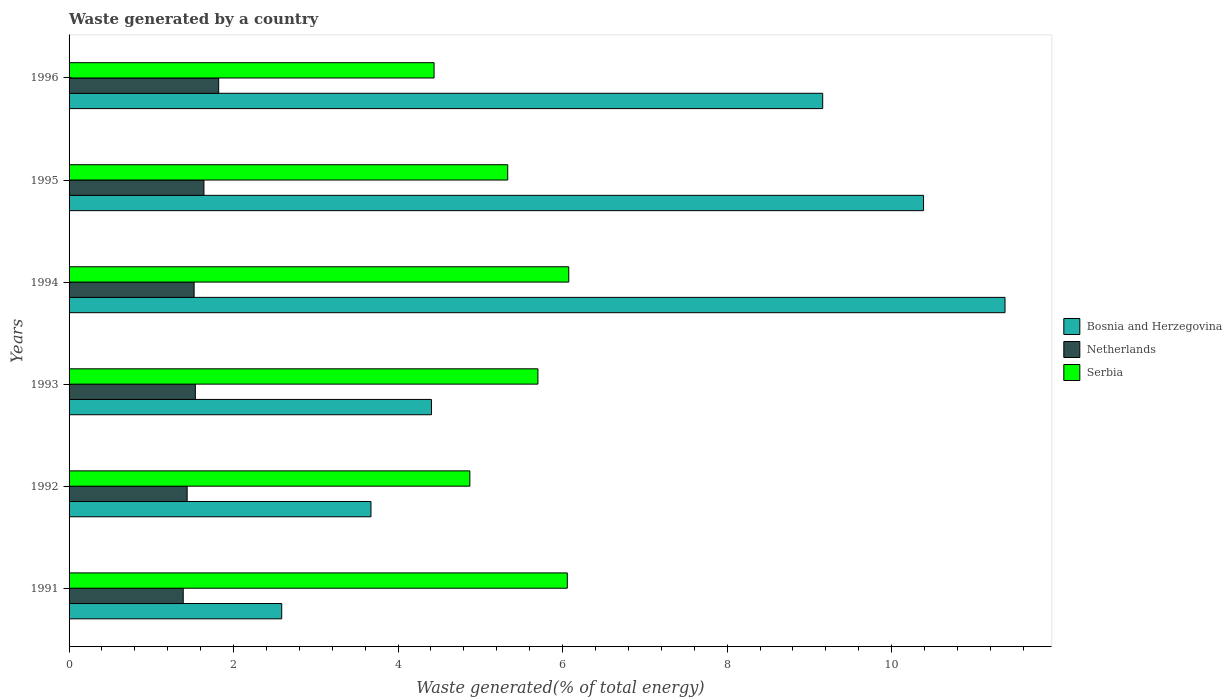Are the number of bars per tick equal to the number of legend labels?
Provide a short and direct response. Yes. How many bars are there on the 1st tick from the top?
Give a very brief answer. 3. How many bars are there on the 4th tick from the bottom?
Offer a very short reply. 3. In how many cases, is the number of bars for a given year not equal to the number of legend labels?
Provide a succinct answer. 0. What is the total waste generated in Serbia in 1993?
Your answer should be compact. 5.7. Across all years, what is the maximum total waste generated in Netherlands?
Make the answer very short. 1.82. Across all years, what is the minimum total waste generated in Serbia?
Your response must be concise. 4.44. In which year was the total waste generated in Netherlands maximum?
Make the answer very short. 1996. In which year was the total waste generated in Serbia minimum?
Offer a very short reply. 1996. What is the total total waste generated in Netherlands in the graph?
Keep it short and to the point. 9.34. What is the difference between the total waste generated in Serbia in 1991 and that in 1996?
Keep it short and to the point. 1.62. What is the difference between the total waste generated in Bosnia and Herzegovina in 1996 and the total waste generated in Serbia in 1991?
Offer a terse response. 3.1. What is the average total waste generated in Serbia per year?
Offer a terse response. 5.41. In the year 1993, what is the difference between the total waste generated in Bosnia and Herzegovina and total waste generated in Netherlands?
Your answer should be compact. 2.87. What is the ratio of the total waste generated in Serbia in 1991 to that in 1995?
Provide a short and direct response. 1.14. What is the difference between the highest and the second highest total waste generated in Bosnia and Herzegovina?
Your answer should be very brief. 0.99. What is the difference between the highest and the lowest total waste generated in Serbia?
Your response must be concise. 1.64. What does the 1st bar from the top in 1991 represents?
Provide a short and direct response. Serbia. What does the 2nd bar from the bottom in 1995 represents?
Ensure brevity in your answer.  Netherlands. Is it the case that in every year, the sum of the total waste generated in Netherlands and total waste generated in Serbia is greater than the total waste generated in Bosnia and Herzegovina?
Your answer should be compact. No. How many bars are there?
Provide a short and direct response. 18. Does the graph contain any zero values?
Your response must be concise. No. How many legend labels are there?
Offer a very short reply. 3. What is the title of the graph?
Give a very brief answer. Waste generated by a country. What is the label or title of the X-axis?
Your response must be concise. Waste generated(% of total energy). What is the label or title of the Y-axis?
Offer a very short reply. Years. What is the Waste generated(% of total energy) in Bosnia and Herzegovina in 1991?
Your answer should be very brief. 2.59. What is the Waste generated(% of total energy) of Netherlands in 1991?
Offer a very short reply. 1.39. What is the Waste generated(% of total energy) of Serbia in 1991?
Ensure brevity in your answer.  6.06. What is the Waste generated(% of total energy) of Bosnia and Herzegovina in 1992?
Your answer should be very brief. 3.67. What is the Waste generated(% of total energy) in Netherlands in 1992?
Ensure brevity in your answer.  1.44. What is the Waste generated(% of total energy) in Serbia in 1992?
Provide a short and direct response. 4.87. What is the Waste generated(% of total energy) in Bosnia and Herzegovina in 1993?
Give a very brief answer. 4.41. What is the Waste generated(% of total energy) in Netherlands in 1993?
Make the answer very short. 1.54. What is the Waste generated(% of total energy) in Serbia in 1993?
Your response must be concise. 5.7. What is the Waste generated(% of total energy) of Bosnia and Herzegovina in 1994?
Give a very brief answer. 11.38. What is the Waste generated(% of total energy) in Netherlands in 1994?
Your answer should be very brief. 1.52. What is the Waste generated(% of total energy) of Serbia in 1994?
Make the answer very short. 6.08. What is the Waste generated(% of total energy) in Bosnia and Herzegovina in 1995?
Make the answer very short. 10.39. What is the Waste generated(% of total energy) of Netherlands in 1995?
Offer a very short reply. 1.64. What is the Waste generated(% of total energy) in Serbia in 1995?
Keep it short and to the point. 5.33. What is the Waste generated(% of total energy) of Bosnia and Herzegovina in 1996?
Your response must be concise. 9.16. What is the Waste generated(% of total energy) of Netherlands in 1996?
Make the answer very short. 1.82. What is the Waste generated(% of total energy) of Serbia in 1996?
Keep it short and to the point. 4.44. Across all years, what is the maximum Waste generated(% of total energy) of Bosnia and Herzegovina?
Ensure brevity in your answer.  11.38. Across all years, what is the maximum Waste generated(% of total energy) of Netherlands?
Offer a terse response. 1.82. Across all years, what is the maximum Waste generated(% of total energy) in Serbia?
Give a very brief answer. 6.08. Across all years, what is the minimum Waste generated(% of total energy) of Bosnia and Herzegovina?
Make the answer very short. 2.59. Across all years, what is the minimum Waste generated(% of total energy) of Netherlands?
Provide a short and direct response. 1.39. Across all years, what is the minimum Waste generated(% of total energy) of Serbia?
Your answer should be very brief. 4.44. What is the total Waste generated(% of total energy) in Bosnia and Herzegovina in the graph?
Keep it short and to the point. 41.59. What is the total Waste generated(% of total energy) in Netherlands in the graph?
Offer a very short reply. 9.34. What is the total Waste generated(% of total energy) of Serbia in the graph?
Offer a very short reply. 32.48. What is the difference between the Waste generated(% of total energy) of Bosnia and Herzegovina in 1991 and that in 1992?
Your response must be concise. -1.09. What is the difference between the Waste generated(% of total energy) in Netherlands in 1991 and that in 1992?
Give a very brief answer. -0.05. What is the difference between the Waste generated(% of total energy) of Serbia in 1991 and that in 1992?
Your answer should be compact. 1.18. What is the difference between the Waste generated(% of total energy) of Bosnia and Herzegovina in 1991 and that in 1993?
Your answer should be very brief. -1.82. What is the difference between the Waste generated(% of total energy) in Netherlands in 1991 and that in 1993?
Provide a short and direct response. -0.15. What is the difference between the Waste generated(% of total energy) in Serbia in 1991 and that in 1993?
Give a very brief answer. 0.36. What is the difference between the Waste generated(% of total energy) of Bosnia and Herzegovina in 1991 and that in 1994?
Your answer should be very brief. -8.79. What is the difference between the Waste generated(% of total energy) in Netherlands in 1991 and that in 1994?
Your answer should be very brief. -0.13. What is the difference between the Waste generated(% of total energy) in Serbia in 1991 and that in 1994?
Provide a short and direct response. -0.02. What is the difference between the Waste generated(% of total energy) of Bosnia and Herzegovina in 1991 and that in 1995?
Your response must be concise. -7.8. What is the difference between the Waste generated(% of total energy) in Netherlands in 1991 and that in 1995?
Give a very brief answer. -0.25. What is the difference between the Waste generated(% of total energy) of Serbia in 1991 and that in 1995?
Keep it short and to the point. 0.72. What is the difference between the Waste generated(% of total energy) of Bosnia and Herzegovina in 1991 and that in 1996?
Provide a succinct answer. -6.58. What is the difference between the Waste generated(% of total energy) of Netherlands in 1991 and that in 1996?
Offer a very short reply. -0.43. What is the difference between the Waste generated(% of total energy) in Serbia in 1991 and that in 1996?
Provide a succinct answer. 1.62. What is the difference between the Waste generated(% of total energy) in Bosnia and Herzegovina in 1992 and that in 1993?
Your answer should be compact. -0.74. What is the difference between the Waste generated(% of total energy) of Netherlands in 1992 and that in 1993?
Your response must be concise. -0.1. What is the difference between the Waste generated(% of total energy) in Serbia in 1992 and that in 1993?
Your answer should be compact. -0.83. What is the difference between the Waste generated(% of total energy) of Bosnia and Herzegovina in 1992 and that in 1994?
Give a very brief answer. -7.71. What is the difference between the Waste generated(% of total energy) in Netherlands in 1992 and that in 1994?
Provide a succinct answer. -0.08. What is the difference between the Waste generated(% of total energy) in Serbia in 1992 and that in 1994?
Make the answer very short. -1.2. What is the difference between the Waste generated(% of total energy) of Bosnia and Herzegovina in 1992 and that in 1995?
Offer a very short reply. -6.72. What is the difference between the Waste generated(% of total energy) of Netherlands in 1992 and that in 1995?
Ensure brevity in your answer.  -0.2. What is the difference between the Waste generated(% of total energy) of Serbia in 1992 and that in 1995?
Your response must be concise. -0.46. What is the difference between the Waste generated(% of total energy) in Bosnia and Herzegovina in 1992 and that in 1996?
Make the answer very short. -5.49. What is the difference between the Waste generated(% of total energy) of Netherlands in 1992 and that in 1996?
Ensure brevity in your answer.  -0.38. What is the difference between the Waste generated(% of total energy) in Serbia in 1992 and that in 1996?
Keep it short and to the point. 0.43. What is the difference between the Waste generated(% of total energy) of Bosnia and Herzegovina in 1993 and that in 1994?
Provide a succinct answer. -6.97. What is the difference between the Waste generated(% of total energy) in Netherlands in 1993 and that in 1994?
Your answer should be compact. 0.01. What is the difference between the Waste generated(% of total energy) of Serbia in 1993 and that in 1994?
Offer a very short reply. -0.38. What is the difference between the Waste generated(% of total energy) in Bosnia and Herzegovina in 1993 and that in 1995?
Provide a succinct answer. -5.98. What is the difference between the Waste generated(% of total energy) in Netherlands in 1993 and that in 1995?
Your answer should be compact. -0.1. What is the difference between the Waste generated(% of total energy) in Serbia in 1993 and that in 1995?
Provide a succinct answer. 0.37. What is the difference between the Waste generated(% of total energy) in Bosnia and Herzegovina in 1993 and that in 1996?
Make the answer very short. -4.76. What is the difference between the Waste generated(% of total energy) of Netherlands in 1993 and that in 1996?
Your answer should be compact. -0.28. What is the difference between the Waste generated(% of total energy) of Serbia in 1993 and that in 1996?
Provide a succinct answer. 1.26. What is the difference between the Waste generated(% of total energy) in Bosnia and Herzegovina in 1994 and that in 1995?
Your answer should be very brief. 0.99. What is the difference between the Waste generated(% of total energy) of Netherlands in 1994 and that in 1995?
Your answer should be compact. -0.12. What is the difference between the Waste generated(% of total energy) in Serbia in 1994 and that in 1995?
Keep it short and to the point. 0.74. What is the difference between the Waste generated(% of total energy) in Bosnia and Herzegovina in 1994 and that in 1996?
Ensure brevity in your answer.  2.22. What is the difference between the Waste generated(% of total energy) of Netherlands in 1994 and that in 1996?
Your answer should be very brief. -0.3. What is the difference between the Waste generated(% of total energy) in Serbia in 1994 and that in 1996?
Your answer should be compact. 1.64. What is the difference between the Waste generated(% of total energy) of Bosnia and Herzegovina in 1995 and that in 1996?
Your answer should be compact. 1.23. What is the difference between the Waste generated(% of total energy) in Netherlands in 1995 and that in 1996?
Your answer should be compact. -0.18. What is the difference between the Waste generated(% of total energy) in Serbia in 1995 and that in 1996?
Your answer should be compact. 0.9. What is the difference between the Waste generated(% of total energy) in Bosnia and Herzegovina in 1991 and the Waste generated(% of total energy) in Netherlands in 1992?
Offer a terse response. 1.15. What is the difference between the Waste generated(% of total energy) of Bosnia and Herzegovina in 1991 and the Waste generated(% of total energy) of Serbia in 1992?
Offer a terse response. -2.29. What is the difference between the Waste generated(% of total energy) in Netherlands in 1991 and the Waste generated(% of total energy) in Serbia in 1992?
Ensure brevity in your answer.  -3.48. What is the difference between the Waste generated(% of total energy) in Bosnia and Herzegovina in 1991 and the Waste generated(% of total energy) in Netherlands in 1993?
Offer a very short reply. 1.05. What is the difference between the Waste generated(% of total energy) of Bosnia and Herzegovina in 1991 and the Waste generated(% of total energy) of Serbia in 1993?
Give a very brief answer. -3.12. What is the difference between the Waste generated(% of total energy) in Netherlands in 1991 and the Waste generated(% of total energy) in Serbia in 1993?
Ensure brevity in your answer.  -4.31. What is the difference between the Waste generated(% of total energy) in Bosnia and Herzegovina in 1991 and the Waste generated(% of total energy) in Netherlands in 1994?
Provide a succinct answer. 1.06. What is the difference between the Waste generated(% of total energy) in Bosnia and Herzegovina in 1991 and the Waste generated(% of total energy) in Serbia in 1994?
Ensure brevity in your answer.  -3.49. What is the difference between the Waste generated(% of total energy) of Netherlands in 1991 and the Waste generated(% of total energy) of Serbia in 1994?
Offer a very short reply. -4.69. What is the difference between the Waste generated(% of total energy) of Bosnia and Herzegovina in 1991 and the Waste generated(% of total energy) of Netherlands in 1995?
Ensure brevity in your answer.  0.95. What is the difference between the Waste generated(% of total energy) in Bosnia and Herzegovina in 1991 and the Waste generated(% of total energy) in Serbia in 1995?
Make the answer very short. -2.75. What is the difference between the Waste generated(% of total energy) of Netherlands in 1991 and the Waste generated(% of total energy) of Serbia in 1995?
Your response must be concise. -3.95. What is the difference between the Waste generated(% of total energy) in Bosnia and Herzegovina in 1991 and the Waste generated(% of total energy) in Netherlands in 1996?
Offer a very short reply. 0.77. What is the difference between the Waste generated(% of total energy) in Bosnia and Herzegovina in 1991 and the Waste generated(% of total energy) in Serbia in 1996?
Offer a very short reply. -1.85. What is the difference between the Waste generated(% of total energy) of Netherlands in 1991 and the Waste generated(% of total energy) of Serbia in 1996?
Keep it short and to the point. -3.05. What is the difference between the Waste generated(% of total energy) of Bosnia and Herzegovina in 1992 and the Waste generated(% of total energy) of Netherlands in 1993?
Your answer should be very brief. 2.14. What is the difference between the Waste generated(% of total energy) of Bosnia and Herzegovina in 1992 and the Waste generated(% of total energy) of Serbia in 1993?
Offer a very short reply. -2.03. What is the difference between the Waste generated(% of total energy) of Netherlands in 1992 and the Waste generated(% of total energy) of Serbia in 1993?
Offer a very short reply. -4.26. What is the difference between the Waste generated(% of total energy) in Bosnia and Herzegovina in 1992 and the Waste generated(% of total energy) in Netherlands in 1994?
Your answer should be compact. 2.15. What is the difference between the Waste generated(% of total energy) of Bosnia and Herzegovina in 1992 and the Waste generated(% of total energy) of Serbia in 1994?
Keep it short and to the point. -2.4. What is the difference between the Waste generated(% of total energy) of Netherlands in 1992 and the Waste generated(% of total energy) of Serbia in 1994?
Your response must be concise. -4.64. What is the difference between the Waste generated(% of total energy) of Bosnia and Herzegovina in 1992 and the Waste generated(% of total energy) of Netherlands in 1995?
Provide a succinct answer. 2.03. What is the difference between the Waste generated(% of total energy) of Bosnia and Herzegovina in 1992 and the Waste generated(% of total energy) of Serbia in 1995?
Your answer should be compact. -1.66. What is the difference between the Waste generated(% of total energy) of Netherlands in 1992 and the Waste generated(% of total energy) of Serbia in 1995?
Your response must be concise. -3.9. What is the difference between the Waste generated(% of total energy) in Bosnia and Herzegovina in 1992 and the Waste generated(% of total energy) in Netherlands in 1996?
Give a very brief answer. 1.85. What is the difference between the Waste generated(% of total energy) in Bosnia and Herzegovina in 1992 and the Waste generated(% of total energy) in Serbia in 1996?
Offer a terse response. -0.77. What is the difference between the Waste generated(% of total energy) in Netherlands in 1992 and the Waste generated(% of total energy) in Serbia in 1996?
Your answer should be very brief. -3. What is the difference between the Waste generated(% of total energy) in Bosnia and Herzegovina in 1993 and the Waste generated(% of total energy) in Netherlands in 1994?
Your answer should be compact. 2.89. What is the difference between the Waste generated(% of total energy) in Bosnia and Herzegovina in 1993 and the Waste generated(% of total energy) in Serbia in 1994?
Provide a short and direct response. -1.67. What is the difference between the Waste generated(% of total energy) in Netherlands in 1993 and the Waste generated(% of total energy) in Serbia in 1994?
Make the answer very short. -4.54. What is the difference between the Waste generated(% of total energy) of Bosnia and Herzegovina in 1993 and the Waste generated(% of total energy) of Netherlands in 1995?
Keep it short and to the point. 2.77. What is the difference between the Waste generated(% of total energy) in Bosnia and Herzegovina in 1993 and the Waste generated(% of total energy) in Serbia in 1995?
Offer a terse response. -0.93. What is the difference between the Waste generated(% of total energy) in Netherlands in 1993 and the Waste generated(% of total energy) in Serbia in 1995?
Offer a very short reply. -3.8. What is the difference between the Waste generated(% of total energy) of Bosnia and Herzegovina in 1993 and the Waste generated(% of total energy) of Netherlands in 1996?
Offer a terse response. 2.59. What is the difference between the Waste generated(% of total energy) of Bosnia and Herzegovina in 1993 and the Waste generated(% of total energy) of Serbia in 1996?
Provide a short and direct response. -0.03. What is the difference between the Waste generated(% of total energy) in Netherlands in 1993 and the Waste generated(% of total energy) in Serbia in 1996?
Your answer should be compact. -2.9. What is the difference between the Waste generated(% of total energy) in Bosnia and Herzegovina in 1994 and the Waste generated(% of total energy) in Netherlands in 1995?
Make the answer very short. 9.74. What is the difference between the Waste generated(% of total energy) of Bosnia and Herzegovina in 1994 and the Waste generated(% of total energy) of Serbia in 1995?
Your answer should be very brief. 6.05. What is the difference between the Waste generated(% of total energy) of Netherlands in 1994 and the Waste generated(% of total energy) of Serbia in 1995?
Your answer should be very brief. -3.81. What is the difference between the Waste generated(% of total energy) of Bosnia and Herzegovina in 1994 and the Waste generated(% of total energy) of Netherlands in 1996?
Offer a very short reply. 9.56. What is the difference between the Waste generated(% of total energy) in Bosnia and Herzegovina in 1994 and the Waste generated(% of total energy) in Serbia in 1996?
Offer a terse response. 6.94. What is the difference between the Waste generated(% of total energy) in Netherlands in 1994 and the Waste generated(% of total energy) in Serbia in 1996?
Give a very brief answer. -2.92. What is the difference between the Waste generated(% of total energy) of Bosnia and Herzegovina in 1995 and the Waste generated(% of total energy) of Netherlands in 1996?
Your response must be concise. 8.57. What is the difference between the Waste generated(% of total energy) of Bosnia and Herzegovina in 1995 and the Waste generated(% of total energy) of Serbia in 1996?
Offer a terse response. 5.95. What is the difference between the Waste generated(% of total energy) in Netherlands in 1995 and the Waste generated(% of total energy) in Serbia in 1996?
Provide a short and direct response. -2.8. What is the average Waste generated(% of total energy) of Bosnia and Herzegovina per year?
Offer a very short reply. 6.93. What is the average Waste generated(% of total energy) of Netherlands per year?
Your answer should be compact. 1.56. What is the average Waste generated(% of total energy) in Serbia per year?
Your answer should be compact. 5.41. In the year 1991, what is the difference between the Waste generated(% of total energy) in Bosnia and Herzegovina and Waste generated(% of total energy) in Netherlands?
Ensure brevity in your answer.  1.2. In the year 1991, what is the difference between the Waste generated(% of total energy) of Bosnia and Herzegovina and Waste generated(% of total energy) of Serbia?
Your answer should be compact. -3.47. In the year 1991, what is the difference between the Waste generated(% of total energy) of Netherlands and Waste generated(% of total energy) of Serbia?
Provide a short and direct response. -4.67. In the year 1992, what is the difference between the Waste generated(% of total energy) in Bosnia and Herzegovina and Waste generated(% of total energy) in Netherlands?
Offer a terse response. 2.23. In the year 1992, what is the difference between the Waste generated(% of total energy) of Bosnia and Herzegovina and Waste generated(% of total energy) of Serbia?
Offer a terse response. -1.2. In the year 1992, what is the difference between the Waste generated(% of total energy) of Netherlands and Waste generated(% of total energy) of Serbia?
Your answer should be compact. -3.44. In the year 1993, what is the difference between the Waste generated(% of total energy) of Bosnia and Herzegovina and Waste generated(% of total energy) of Netherlands?
Offer a very short reply. 2.87. In the year 1993, what is the difference between the Waste generated(% of total energy) in Bosnia and Herzegovina and Waste generated(% of total energy) in Serbia?
Your response must be concise. -1.29. In the year 1993, what is the difference between the Waste generated(% of total energy) of Netherlands and Waste generated(% of total energy) of Serbia?
Your answer should be very brief. -4.16. In the year 1994, what is the difference between the Waste generated(% of total energy) in Bosnia and Herzegovina and Waste generated(% of total energy) in Netherlands?
Keep it short and to the point. 9.86. In the year 1994, what is the difference between the Waste generated(% of total energy) in Bosnia and Herzegovina and Waste generated(% of total energy) in Serbia?
Make the answer very short. 5.3. In the year 1994, what is the difference between the Waste generated(% of total energy) of Netherlands and Waste generated(% of total energy) of Serbia?
Keep it short and to the point. -4.55. In the year 1995, what is the difference between the Waste generated(% of total energy) in Bosnia and Herzegovina and Waste generated(% of total energy) in Netherlands?
Your answer should be very brief. 8.75. In the year 1995, what is the difference between the Waste generated(% of total energy) of Bosnia and Herzegovina and Waste generated(% of total energy) of Serbia?
Make the answer very short. 5.06. In the year 1995, what is the difference between the Waste generated(% of total energy) in Netherlands and Waste generated(% of total energy) in Serbia?
Give a very brief answer. -3.69. In the year 1996, what is the difference between the Waste generated(% of total energy) of Bosnia and Herzegovina and Waste generated(% of total energy) of Netherlands?
Ensure brevity in your answer.  7.34. In the year 1996, what is the difference between the Waste generated(% of total energy) in Bosnia and Herzegovina and Waste generated(% of total energy) in Serbia?
Your answer should be very brief. 4.72. In the year 1996, what is the difference between the Waste generated(% of total energy) in Netherlands and Waste generated(% of total energy) in Serbia?
Offer a terse response. -2.62. What is the ratio of the Waste generated(% of total energy) of Bosnia and Herzegovina in 1991 to that in 1992?
Your answer should be compact. 0.7. What is the ratio of the Waste generated(% of total energy) of Netherlands in 1991 to that in 1992?
Provide a short and direct response. 0.97. What is the ratio of the Waste generated(% of total energy) in Serbia in 1991 to that in 1992?
Make the answer very short. 1.24. What is the ratio of the Waste generated(% of total energy) of Bosnia and Herzegovina in 1991 to that in 1993?
Give a very brief answer. 0.59. What is the ratio of the Waste generated(% of total energy) in Netherlands in 1991 to that in 1993?
Your response must be concise. 0.9. What is the ratio of the Waste generated(% of total energy) of Serbia in 1991 to that in 1993?
Your answer should be compact. 1.06. What is the ratio of the Waste generated(% of total energy) in Bosnia and Herzegovina in 1991 to that in 1994?
Offer a very short reply. 0.23. What is the ratio of the Waste generated(% of total energy) of Netherlands in 1991 to that in 1994?
Make the answer very short. 0.91. What is the ratio of the Waste generated(% of total energy) of Bosnia and Herzegovina in 1991 to that in 1995?
Provide a short and direct response. 0.25. What is the ratio of the Waste generated(% of total energy) in Netherlands in 1991 to that in 1995?
Keep it short and to the point. 0.85. What is the ratio of the Waste generated(% of total energy) of Serbia in 1991 to that in 1995?
Offer a very short reply. 1.14. What is the ratio of the Waste generated(% of total energy) of Bosnia and Herzegovina in 1991 to that in 1996?
Offer a terse response. 0.28. What is the ratio of the Waste generated(% of total energy) of Netherlands in 1991 to that in 1996?
Provide a short and direct response. 0.76. What is the ratio of the Waste generated(% of total energy) of Serbia in 1991 to that in 1996?
Ensure brevity in your answer.  1.36. What is the ratio of the Waste generated(% of total energy) in Bosnia and Herzegovina in 1992 to that in 1993?
Ensure brevity in your answer.  0.83. What is the ratio of the Waste generated(% of total energy) in Netherlands in 1992 to that in 1993?
Provide a short and direct response. 0.94. What is the ratio of the Waste generated(% of total energy) in Serbia in 1992 to that in 1993?
Ensure brevity in your answer.  0.85. What is the ratio of the Waste generated(% of total energy) in Bosnia and Herzegovina in 1992 to that in 1994?
Offer a very short reply. 0.32. What is the ratio of the Waste generated(% of total energy) in Netherlands in 1992 to that in 1994?
Offer a terse response. 0.94. What is the ratio of the Waste generated(% of total energy) of Serbia in 1992 to that in 1994?
Your answer should be compact. 0.8. What is the ratio of the Waste generated(% of total energy) in Bosnia and Herzegovina in 1992 to that in 1995?
Offer a terse response. 0.35. What is the ratio of the Waste generated(% of total energy) in Netherlands in 1992 to that in 1995?
Offer a terse response. 0.88. What is the ratio of the Waste generated(% of total energy) of Serbia in 1992 to that in 1995?
Your answer should be very brief. 0.91. What is the ratio of the Waste generated(% of total energy) in Bosnia and Herzegovina in 1992 to that in 1996?
Provide a short and direct response. 0.4. What is the ratio of the Waste generated(% of total energy) of Netherlands in 1992 to that in 1996?
Ensure brevity in your answer.  0.79. What is the ratio of the Waste generated(% of total energy) of Serbia in 1992 to that in 1996?
Provide a short and direct response. 1.1. What is the ratio of the Waste generated(% of total energy) of Bosnia and Herzegovina in 1993 to that in 1994?
Offer a terse response. 0.39. What is the ratio of the Waste generated(% of total energy) of Netherlands in 1993 to that in 1994?
Your answer should be compact. 1.01. What is the ratio of the Waste generated(% of total energy) of Serbia in 1993 to that in 1994?
Make the answer very short. 0.94. What is the ratio of the Waste generated(% of total energy) in Bosnia and Herzegovina in 1993 to that in 1995?
Offer a terse response. 0.42. What is the ratio of the Waste generated(% of total energy) in Netherlands in 1993 to that in 1995?
Offer a terse response. 0.94. What is the ratio of the Waste generated(% of total energy) in Serbia in 1993 to that in 1995?
Offer a terse response. 1.07. What is the ratio of the Waste generated(% of total energy) of Bosnia and Herzegovina in 1993 to that in 1996?
Offer a terse response. 0.48. What is the ratio of the Waste generated(% of total energy) in Netherlands in 1993 to that in 1996?
Your answer should be compact. 0.84. What is the ratio of the Waste generated(% of total energy) in Serbia in 1993 to that in 1996?
Provide a succinct answer. 1.28. What is the ratio of the Waste generated(% of total energy) in Bosnia and Herzegovina in 1994 to that in 1995?
Provide a succinct answer. 1.1. What is the ratio of the Waste generated(% of total energy) of Netherlands in 1994 to that in 1995?
Your answer should be very brief. 0.93. What is the ratio of the Waste generated(% of total energy) in Serbia in 1994 to that in 1995?
Offer a very short reply. 1.14. What is the ratio of the Waste generated(% of total energy) of Bosnia and Herzegovina in 1994 to that in 1996?
Give a very brief answer. 1.24. What is the ratio of the Waste generated(% of total energy) in Netherlands in 1994 to that in 1996?
Your answer should be compact. 0.84. What is the ratio of the Waste generated(% of total energy) of Serbia in 1994 to that in 1996?
Ensure brevity in your answer.  1.37. What is the ratio of the Waste generated(% of total energy) of Bosnia and Herzegovina in 1995 to that in 1996?
Your answer should be compact. 1.13. What is the ratio of the Waste generated(% of total energy) in Netherlands in 1995 to that in 1996?
Provide a succinct answer. 0.9. What is the ratio of the Waste generated(% of total energy) of Serbia in 1995 to that in 1996?
Your answer should be compact. 1.2. What is the difference between the highest and the second highest Waste generated(% of total energy) of Bosnia and Herzegovina?
Your answer should be compact. 0.99. What is the difference between the highest and the second highest Waste generated(% of total energy) of Netherlands?
Your answer should be very brief. 0.18. What is the difference between the highest and the second highest Waste generated(% of total energy) of Serbia?
Provide a succinct answer. 0.02. What is the difference between the highest and the lowest Waste generated(% of total energy) in Bosnia and Herzegovina?
Make the answer very short. 8.79. What is the difference between the highest and the lowest Waste generated(% of total energy) in Netherlands?
Offer a terse response. 0.43. What is the difference between the highest and the lowest Waste generated(% of total energy) in Serbia?
Offer a very short reply. 1.64. 